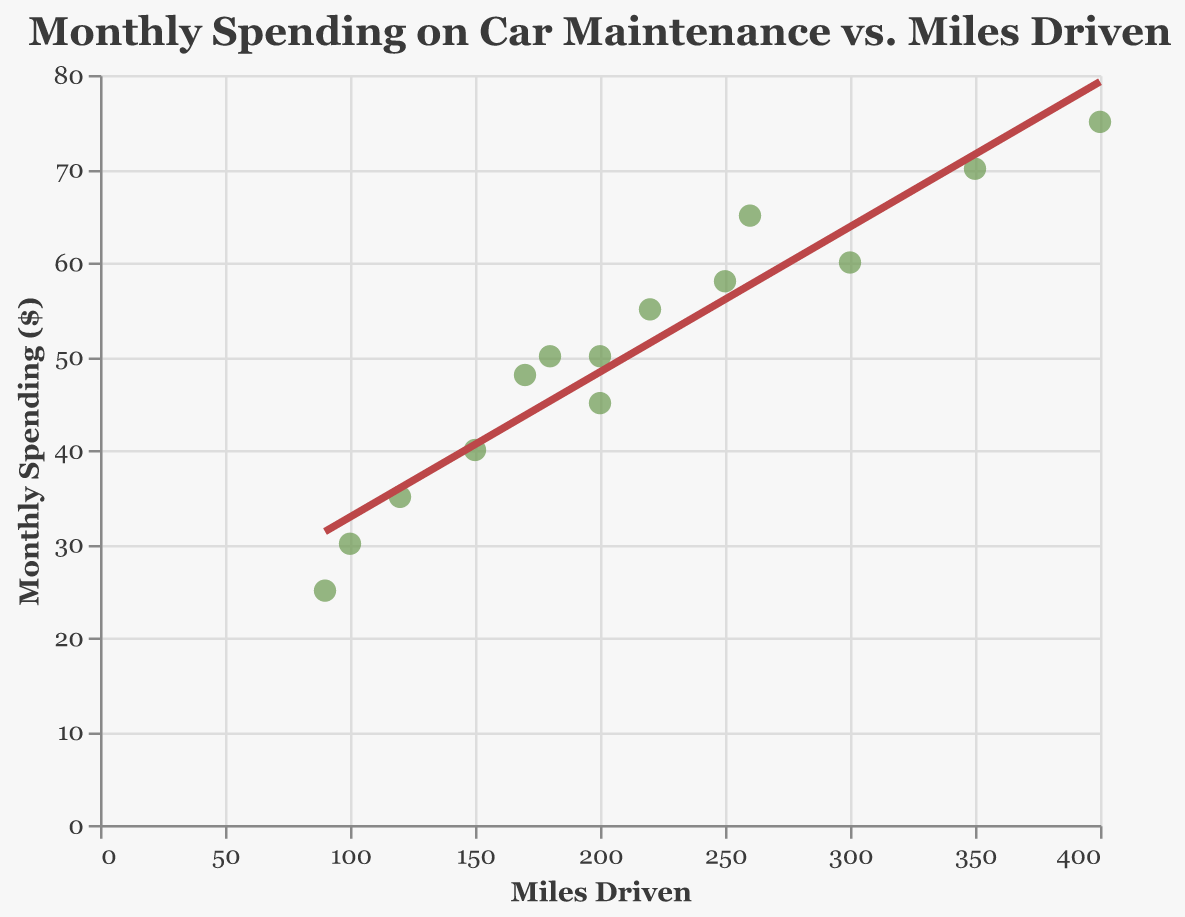What is the title of the scatter plot? The title is displayed at the top of the chart, and it clearly states the main focus of the visual.
Answer: "Monthly Spending on Car Maintenance vs. Miles Driven" How many data points are represented in the scatter plot? By counting the individual points on the scatter plot, you can determine the total number of data points.
Answer: 14 Which axes represent ‘Miles Driven’ and ‘Monthly Spending on Car Maintenance’? The x-axis represents 'Miles Driven' and the y-axis represents 'Monthly Spending on Car Maintenance,' as indicated by the labels on the axes.
Answer: x-axis: Miles Driven, y-axis: Monthly Spending on Car Maintenance What is the color of the trend line? By observing the line that fits through the data points, you can identify its color.
Answer: Red What pattern or relationship can be observed between miles driven and monthly spending on car maintenance? The trend line indicates a positive correlation, meaning as the miles driven increase, the monthly spending on car maintenance also tends to increase.
Answer: Positive correlation What approximate monthly spending is indicated for driving 300 miles? Find the point where the x-axis value is 300 miles and observe the corresponding y-axis value or use the trend line to estimate the spending.
Answer: Approximately $60 What is the maximum monthly spending recorded in the data? Look for the highest point on the y-axis among the data points.
Answer: $75 Is borrowing a vehicle only for short distances more cost-effective in terms of maintenance? Compare the monthly spending data for lower miles driven with higher miles driven to see if lower mileage generally results in lower spending.
Answer: Yes Among the data points, which mileage value corresponds to the lowest maintenance spending, and what is that spending? Identify the data point with the lowest value on the y-axis and find its corresponding value on the x-axis.
Answer: 90 miles, $25 How does the monthly spending on car maintenance change as the miles driven increase from 200 to 300? Compare the spending values at 200 miles and 300 miles by looking at the data points or the trend line at these x-values.
Answer: It increases from approximately $45 to $60 